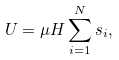<formula> <loc_0><loc_0><loc_500><loc_500>U = \mu H \sum _ { i = 1 } ^ { N } s _ { i } ,</formula> 